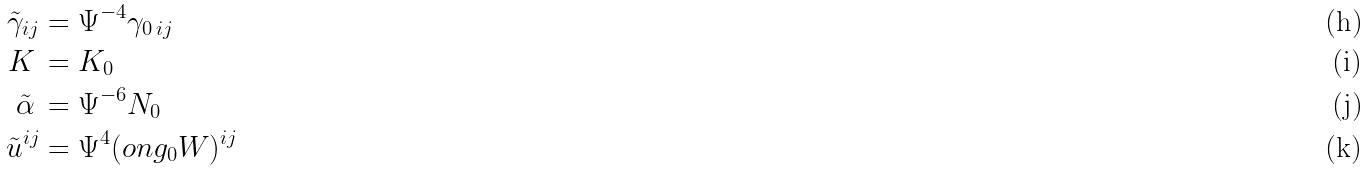Convert formula to latex. <formula><loc_0><loc_0><loc_500><loc_500>\tilde { \gamma } _ { i j } & = \Psi ^ { - 4 } \gamma _ { 0 \, i j } \\ K \, & = K _ { 0 } \\ \tilde { \alpha } \, & = \Psi ^ { - 6 } N _ { 0 } \\ \tilde { u } ^ { i j } & = \Psi ^ { 4 } ( \L o n g _ { 0 } W ) ^ { i j }</formula> 